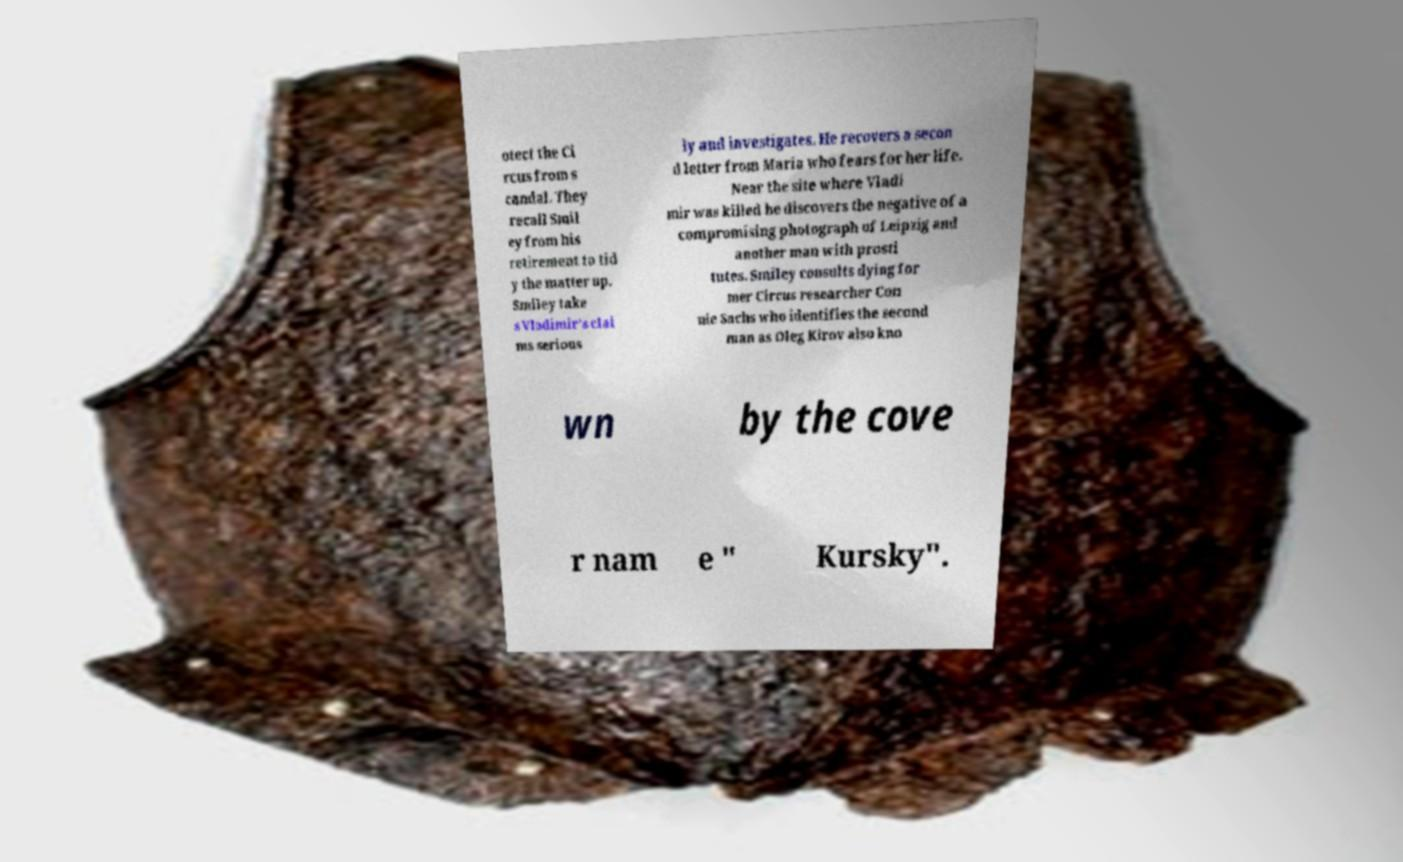For documentation purposes, I need the text within this image transcribed. Could you provide that? otect the Ci rcus from s candal. They recall Smil ey from his retirement to tid y the matter up. Smiley take s Vladimir's clai ms serious ly and investigates. He recovers a secon d letter from Maria who fears for her life. Near the site where Vladi mir was killed he discovers the negative of a compromising photograph of Leipzig and another man with prosti tutes. Smiley consults dying for mer Circus researcher Con nie Sachs who identifies the second man as Oleg Kirov also kno wn by the cove r nam e " Kursky". 